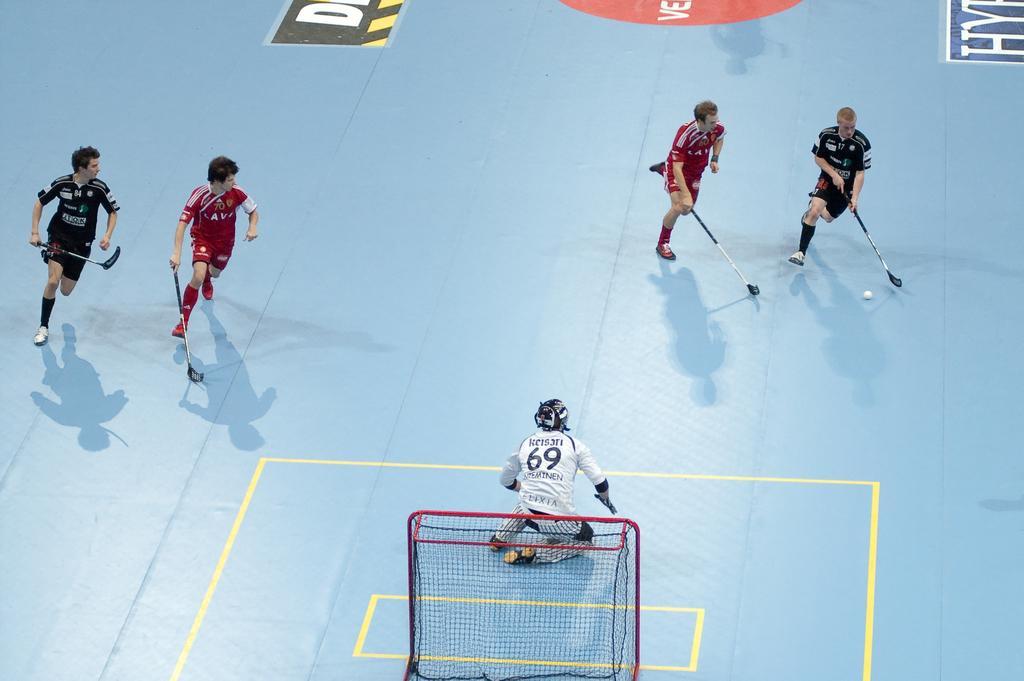In one or two sentences, can you explain what this image depicts? In this image in the center there are some persons who are holding some sticks and it seems that they are playing something, and at the bottom of the image there is a net and one person is sitting and at the bottom there is a board. On the board there is text. 